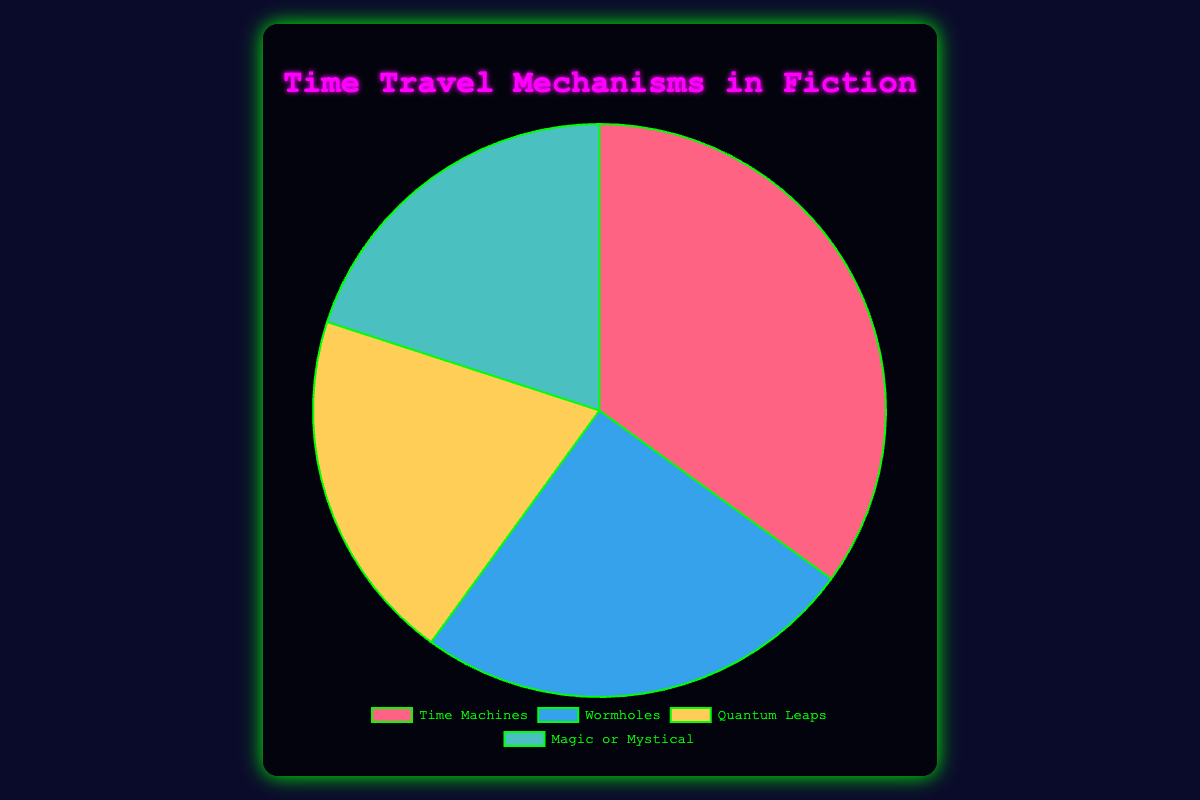What is the most popular type of time travel mechanism featured in fiction? The largest slice of the pie chart represents the most popular type. Here, the "Time Machines" segment takes up 35% of the chart, making it the most popular.
Answer: Time Machines Which two types of time travel mechanisms are equally featured in fiction? Check the percentages of each type in the pie chart. "Quantum Leaps" and "Magic or Mystical" both occupy 20% of the chart.
Answer: Quantum Leaps and Magic or Mystical By how much does the percentage of Time Machines exceed Wormholes? Subtract the percentage of Wormholes (25%) from Time Machines (35%). The difference is 10%.
Answer: 10% What is the total percentage of non-technological time travel mechanisms combined? Sum the percentages of "Quantum Leaps" and "Magic or Mystical," which are both considered non-technological. 20% + 20% = 40%.
Answer: 40% Which travel mechanism type is the least featured in fiction and what percentage of the total does it account for? Compare the percentages of all types. Both "Quantum Leaps" and "Magic or Mystical" are the least featured types, each with 20%.
Answer: Quantum Leaps and Magic or Mystical, 20% What is the percentage difference between the most and least featured time travel mechanisms? Subtract the percentage of the least featured mechanisms (20%) from the most featured mechanism (35%). The difference is 15%.
Answer: 15% What proportion of the time travel mechanisms are technological (Time Machines and Wormholes)? Sum the percentages of "Time Machines" (35%) and "Wormholes" (25%). 35% + 25% = 60%.
Answer: 60% Identify the mechanism type represented by the blue section of the pie chart and its corresponding percentage. Check the color representation in the chart. The blue section (usually) corresponds to "Wormholes" with a percentage of 25%.
Answer: Wormholes, 25% 